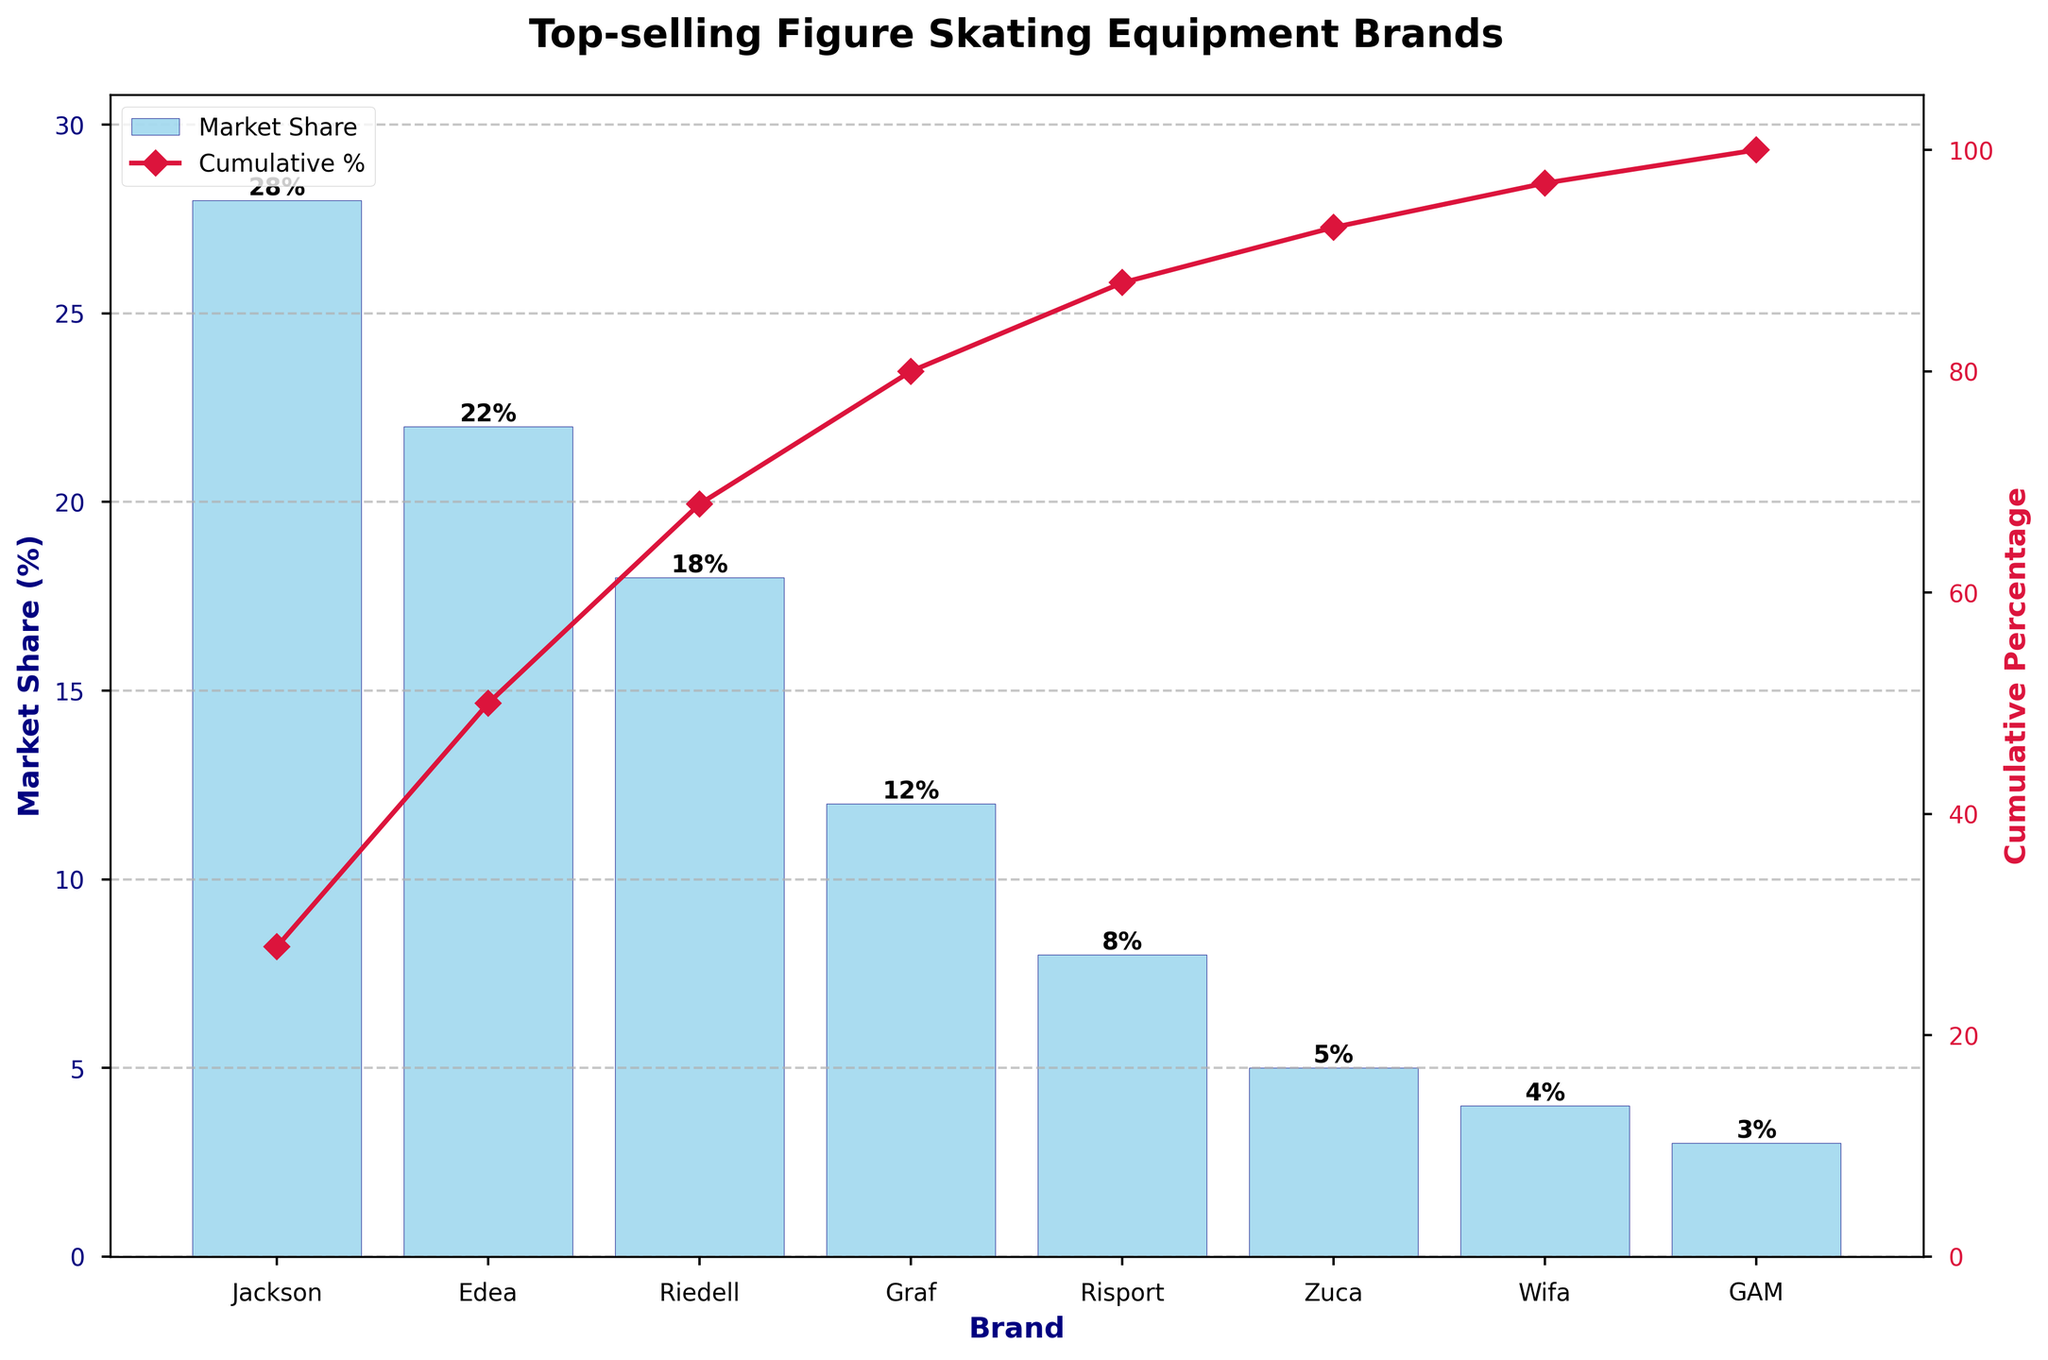what is the largest brand by market share? The largest brand by market share is identified by the highest bar on the plot. This bar corresponds to Jackson, which reaches a market share of 28%.
Answer: Jackson How many brands are shown in the figure? Each bar on the plot represents a brand. Counting these bars gives the total number of brands, which is 8.
Answer: 8 What is the cumulative percentage for Edea? The cumulative percentage for Edea is shown by the line plot. Edea is the second bar, and the corresponding cumulative percentage is around 50%.
Answer: 50% Which brands together make up more than 50% of the market share? By adding the market shares in descending order until the sum surpasses 50%, we get Jackson (28%) + Edea (22%) = 50%, so together, they make up more than 50%.
Answer: Jackson and Edea What are the market shares of Graf and Risport combined? The market shares for Graf and Risport need to be summed. Graf has 12%, and Risport has 8%, so the combined market share is 12% + 8% = 20%.
Answer: 20% Which brand ranks fourth in terms of market share? The fourth brand can be identified by the fourth tallest bar, which is Graf with a market share of 12%.
Answer: Graf Is there a significant drop in market share percentage after the third brand? Comparing the heights of the bars visually, Riedell (third) has 18% and Graf (fourth) has 12%. This shows a decrease of 6%. This might be considered significant.
Answer: Yes What is the cumulative percentage when including the fifth brand? Adding the market shares from the top until the fifth brand, we have Jackson (28%) + Edea (22%) + Riedell (18%) + Graf (12%) + Risport (8%) = 88%. The cumulative percentage is around 88%.
Answer: 88% What is the difference in market share percentage between the top brand and the bottom brand? Subtracting the market share of the smallest brand from the largest gives Jackson (28%) - GAM (3%) = 25%.
Answer: 25% Which brands form the cumulative percentage between 70% and 90%? The cumulative percentage between 70% and 90% includes Graf (12%) and Risport (8%), added after Jackson, Edea, and Riedell which together form 68%. Thus, with Graf and Risport, the cumulative percentage reaches 88%.
Answer: Graf and Risport 